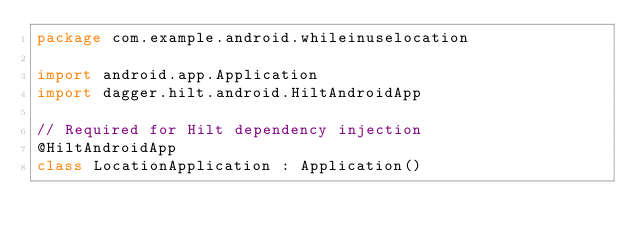<code> <loc_0><loc_0><loc_500><loc_500><_Kotlin_>package com.example.android.whileinuselocation

import android.app.Application
import dagger.hilt.android.HiltAndroidApp

// Required for Hilt dependency injection
@HiltAndroidApp
class LocationApplication : Application()</code> 